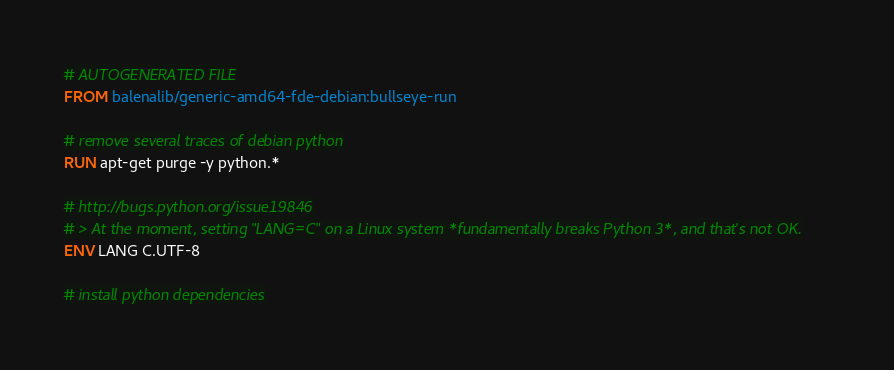<code> <loc_0><loc_0><loc_500><loc_500><_Dockerfile_># AUTOGENERATED FILE
FROM balenalib/generic-amd64-fde-debian:bullseye-run

# remove several traces of debian python
RUN apt-get purge -y python.*

# http://bugs.python.org/issue19846
# > At the moment, setting "LANG=C" on a Linux system *fundamentally breaks Python 3*, and that's not OK.
ENV LANG C.UTF-8

# install python dependencies</code> 